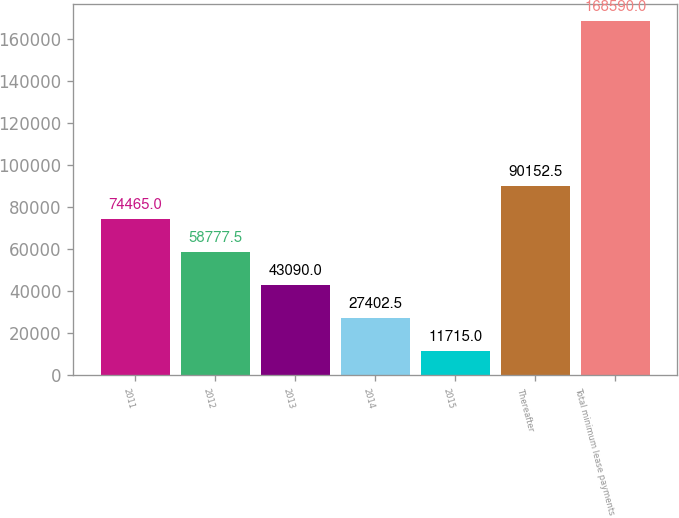Convert chart. <chart><loc_0><loc_0><loc_500><loc_500><bar_chart><fcel>2011<fcel>2012<fcel>2013<fcel>2014<fcel>2015<fcel>Thereafter<fcel>Total minimum lease payments<nl><fcel>74465<fcel>58777.5<fcel>43090<fcel>27402.5<fcel>11715<fcel>90152.5<fcel>168590<nl></chart> 